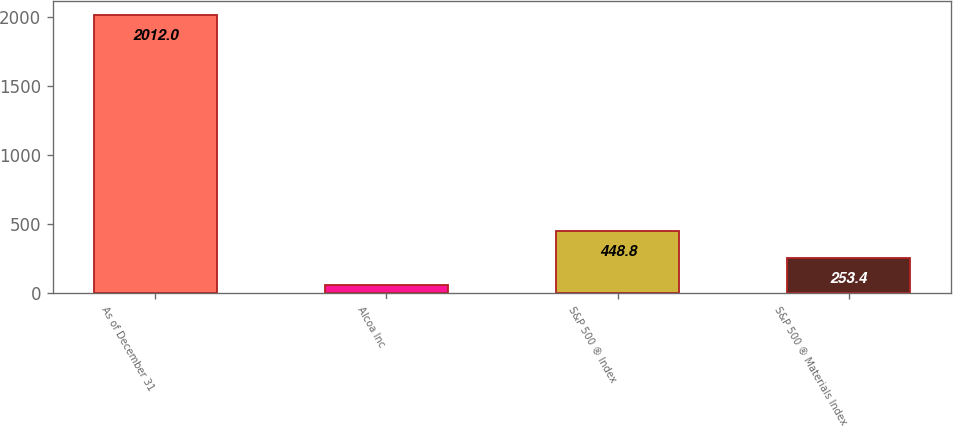Convert chart to OTSL. <chart><loc_0><loc_0><loc_500><loc_500><bar_chart><fcel>As of December 31<fcel>Alcoa Inc<fcel>S&P 500 ® Index<fcel>S&P 500 ® Materials Index<nl><fcel>2012<fcel>58<fcel>448.8<fcel>253.4<nl></chart> 